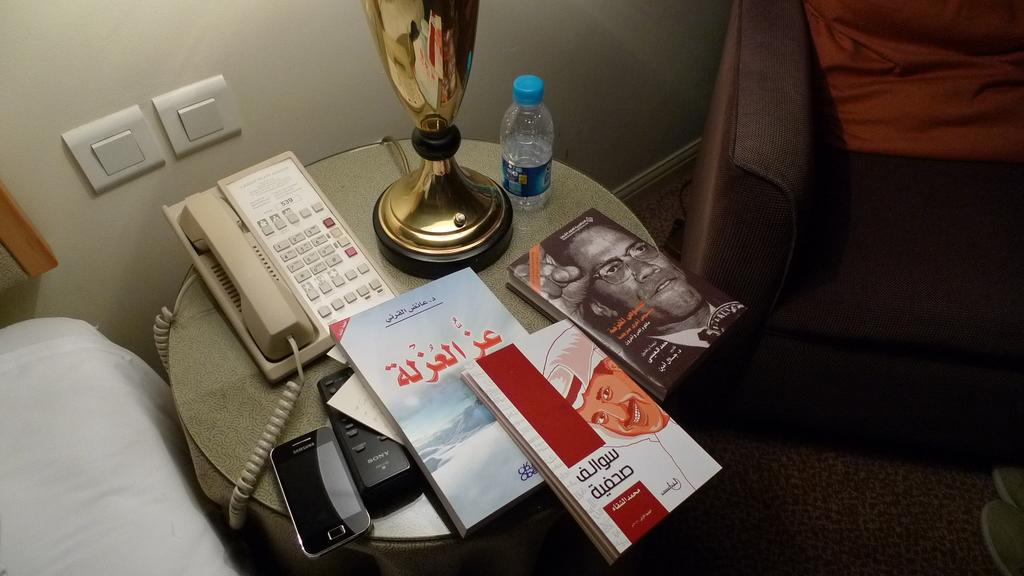What is the brand name of the phone?
Give a very brief answer. Samsung. 